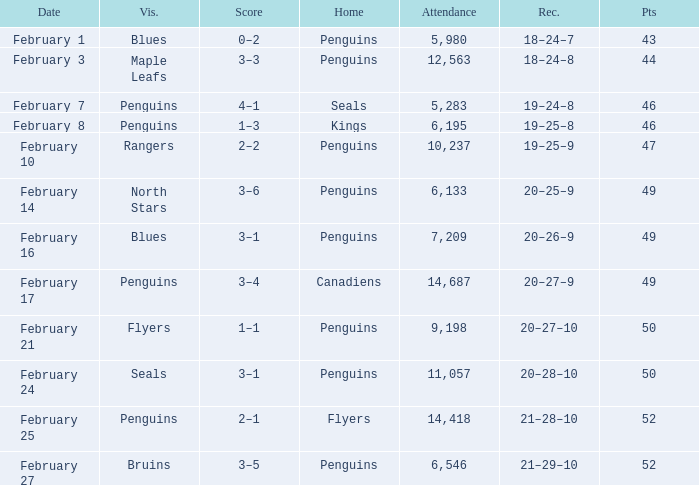Home of kings had what score? 1–3. 